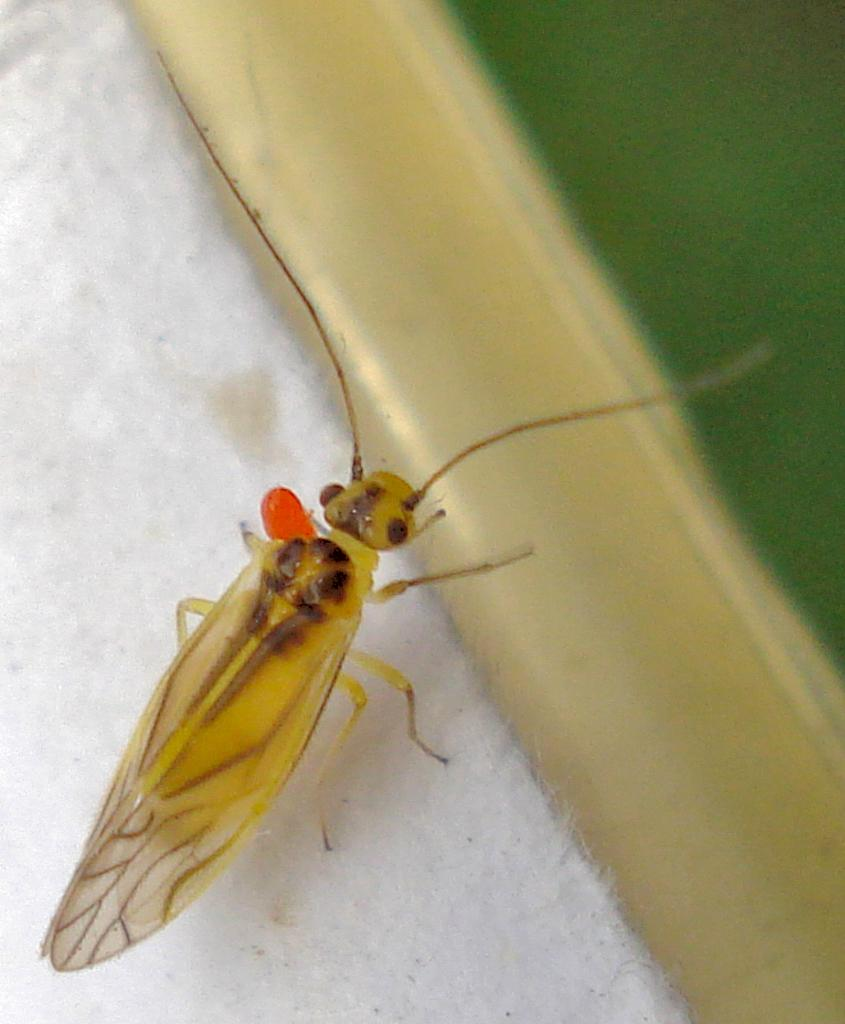What type of insect is in the image? There is a Net-winged insect in the image. Where is the insect located in the image? The insect is present over a place in the image. What degree does the elbow of the insect have in the image? There is no mention of an elbow in the image, as insects do not have elbows. The insect in the image is a Net-winged insect, which has wings and legs, but no elbows. 